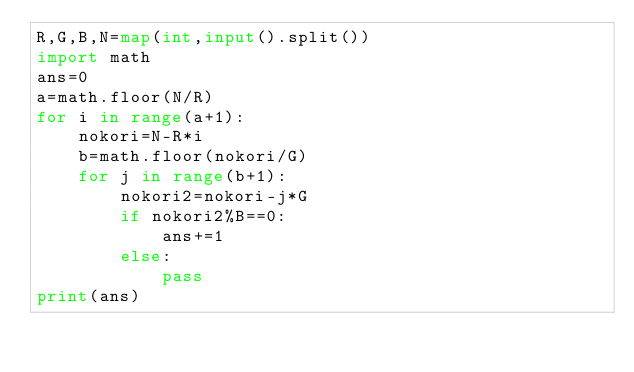Convert code to text. <code><loc_0><loc_0><loc_500><loc_500><_Python_>R,G,B,N=map(int,input().split())
import math
ans=0
a=math.floor(N/R)
for i in range(a+1):
    nokori=N-R*i
    b=math.floor(nokori/G)
    for j in range(b+1):
        nokori2=nokori-j*G
        if nokori2%B==0:
            ans+=1
        else:
            pass
print(ans)</code> 